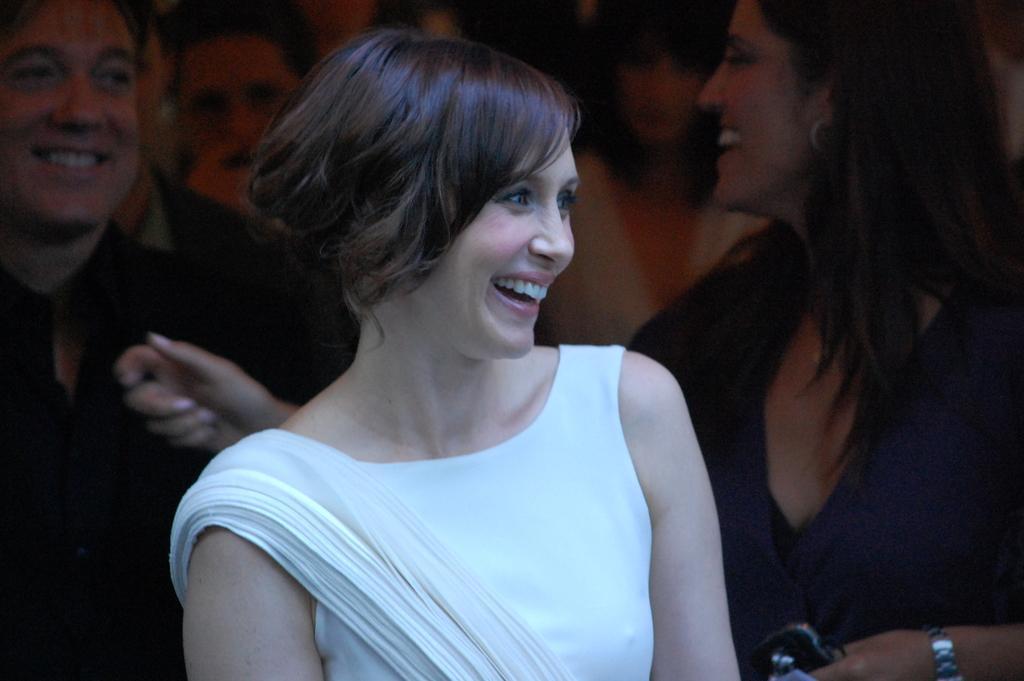How would you summarize this image in a sentence or two? In this image in the foreground a lady wearing white dress is smiling. In the background there are many people. They all are smiling. 